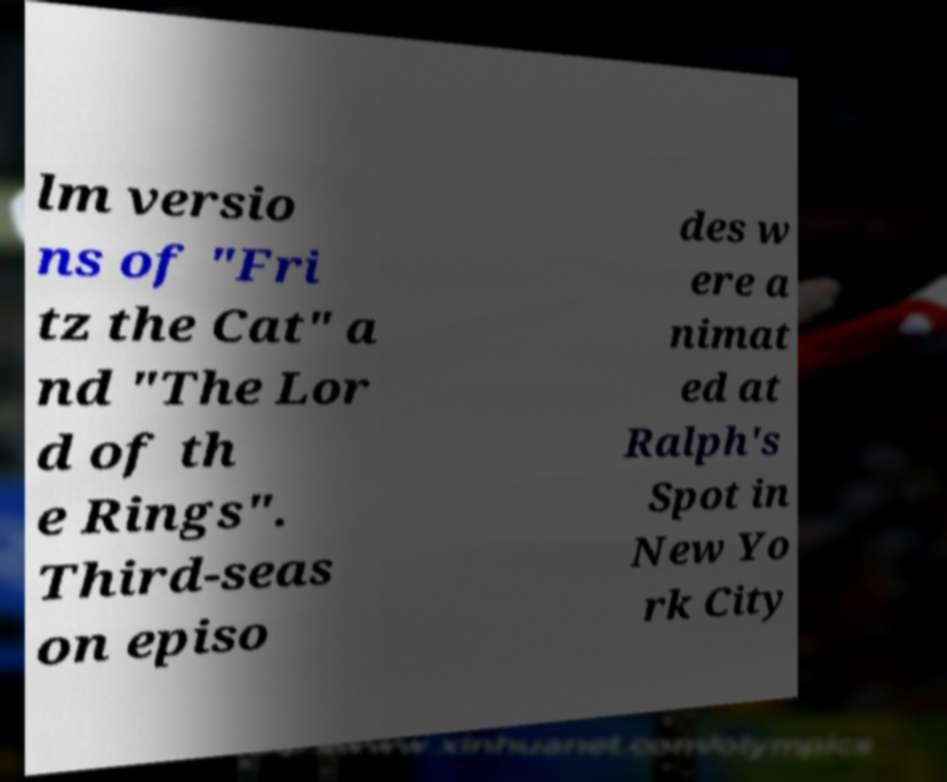Please identify and transcribe the text found in this image. lm versio ns of "Fri tz the Cat" a nd "The Lor d of th e Rings". Third-seas on episo des w ere a nimat ed at Ralph's Spot in New Yo rk City 